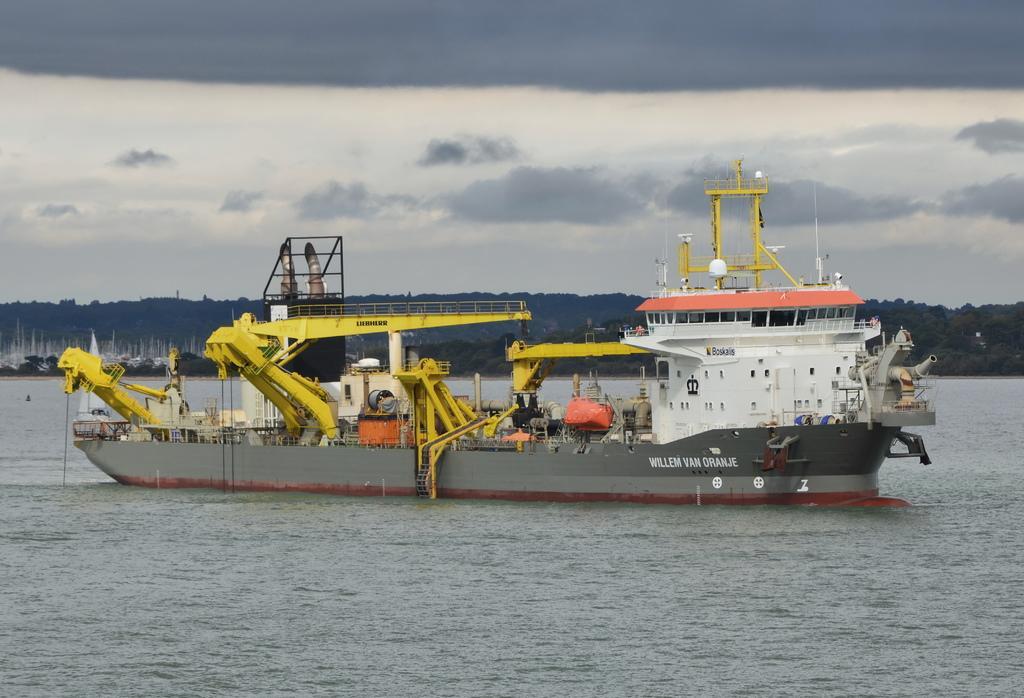Could you give a brief overview of what you see in this image? In this image I can see water and in it I can see a ship. I can also see something is written over here. In the background I can see clouds, sky and trees. 